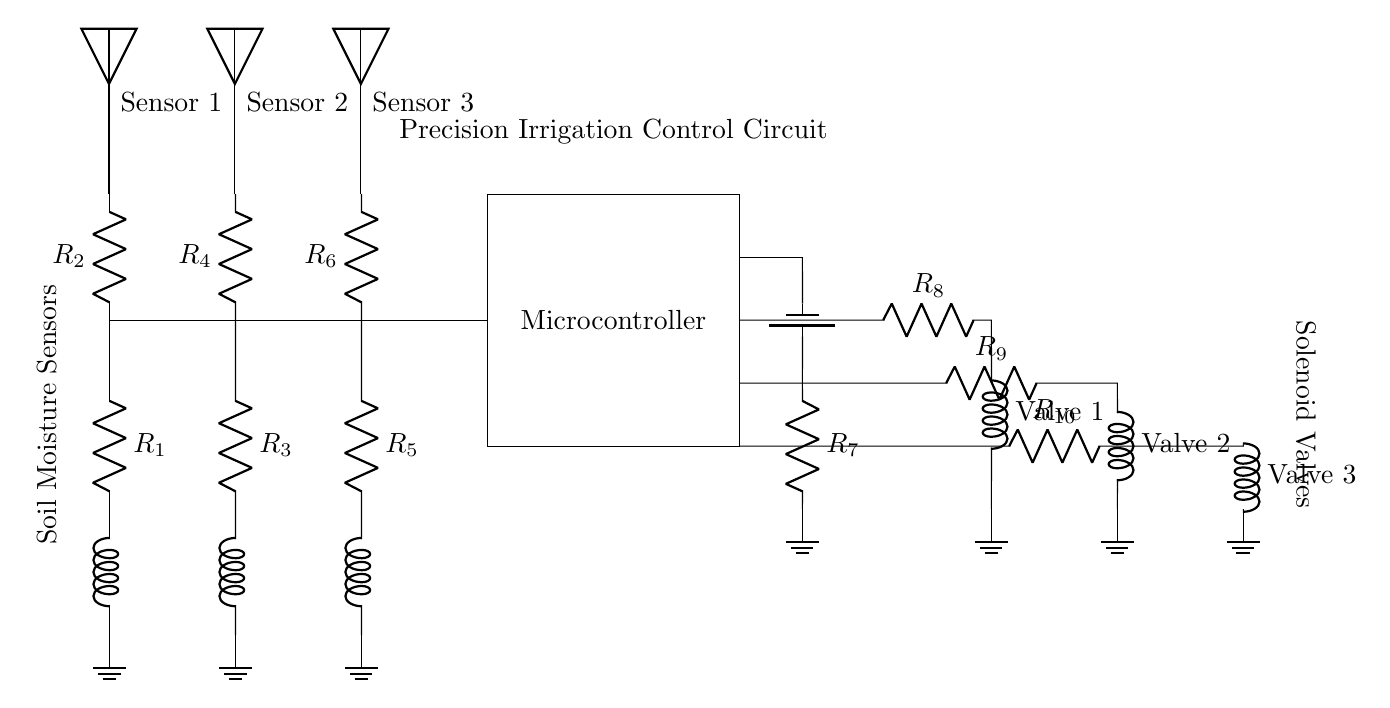What components are used in this circuit? The circuit includes soil moisture sensors, a microcontroller, solenoid valves, resistors, and a power supply. Each component serves a specific function in controlling irrigation based on soil moisture levels.
Answer: soil moisture sensors, microcontroller, solenoid valves, resistors, power supply How many soil moisture sensors are in the circuit? There are three soil moisture sensors depicted in the diagram, each representing a different sensing point within the crop field.
Answer: three What is the purpose of the microcontroller in this circuit? The microcontroller processes the data from the soil moisture sensors and triggers the solenoid valves based on the readings to control irrigation effectively.
Answer: data processing and control Which components are used as solenoid valves? The circuit has three solenoid valves that are identified as Valve 1, Valve 2, and Valve 3, used to control the flow of water to the crop fields.
Answer: Valve 1, Valve 2, Valve 3 How are the soil moisture sensors connected to the microcontroller? The soil moisture sensors are connected in parallel to the microcontroller, allowing it to monitor each sensor's output simultaneously and make irrigation decisions accordingly.
Answer: parallel connection What role do the resistors play in this circuit? The resistors are likely used for current limiting and signal conditioning, ensuring that the components operate correctly without exceeding their ratings. They also help in voltage division for the sensors.
Answer: current limiting and signal conditioning What is the configuration of the solenoid valves in relation to the microcontroller? The solenoid valves are connected in series to the output of the microcontroller, which means that each valve can be operated independently based on the moisture levels detected by the sensors.
Answer: series connection 